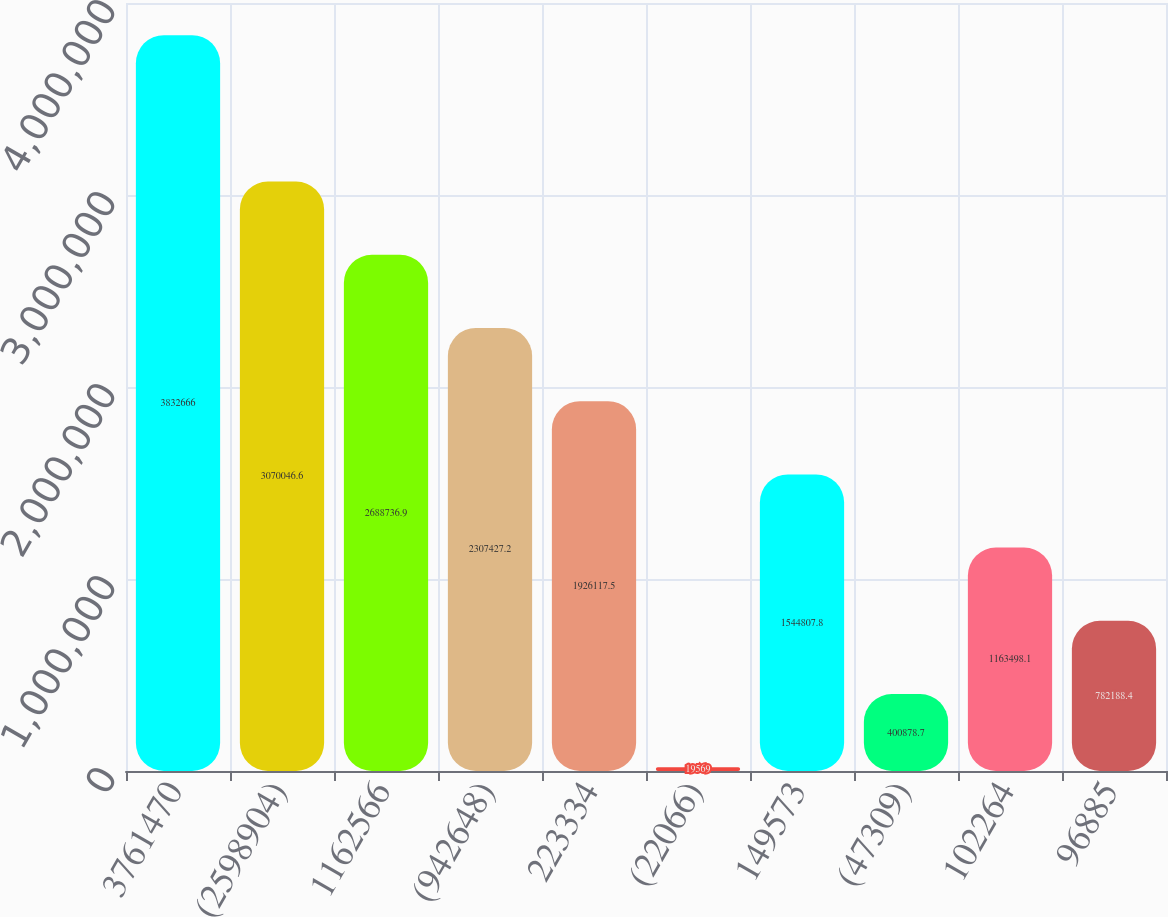Convert chart to OTSL. <chart><loc_0><loc_0><loc_500><loc_500><bar_chart><fcel>3761470<fcel>(2598904)<fcel>1162566<fcel>(942648)<fcel>223334<fcel>(22066)<fcel>149573<fcel>(47309)<fcel>102264<fcel>96885<nl><fcel>3.83267e+06<fcel>3.07005e+06<fcel>2.68874e+06<fcel>2.30743e+06<fcel>1.92612e+06<fcel>19569<fcel>1.54481e+06<fcel>400879<fcel>1.1635e+06<fcel>782188<nl></chart> 